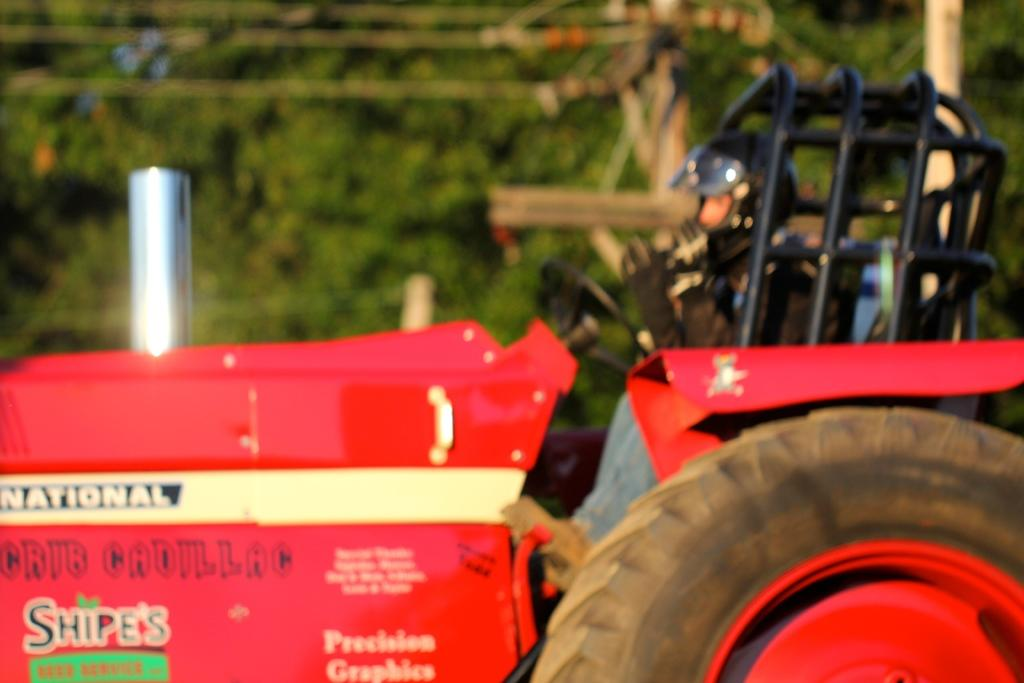What is the main subject of the image? There is a tractor in the image. Who is on the tractor? A person is sitting on the tractor. What safety precaution is the person taking? The person is wearing a helmet. What can be seen in the background of the image? There are trees visible in the image. How would you describe the quality of the image? The image is slightly blurry. What type of yarn is the person using to observe the trees in the image? There is no yarn present in the image, nor is there any indication that the person is using yarn to observe the trees. 